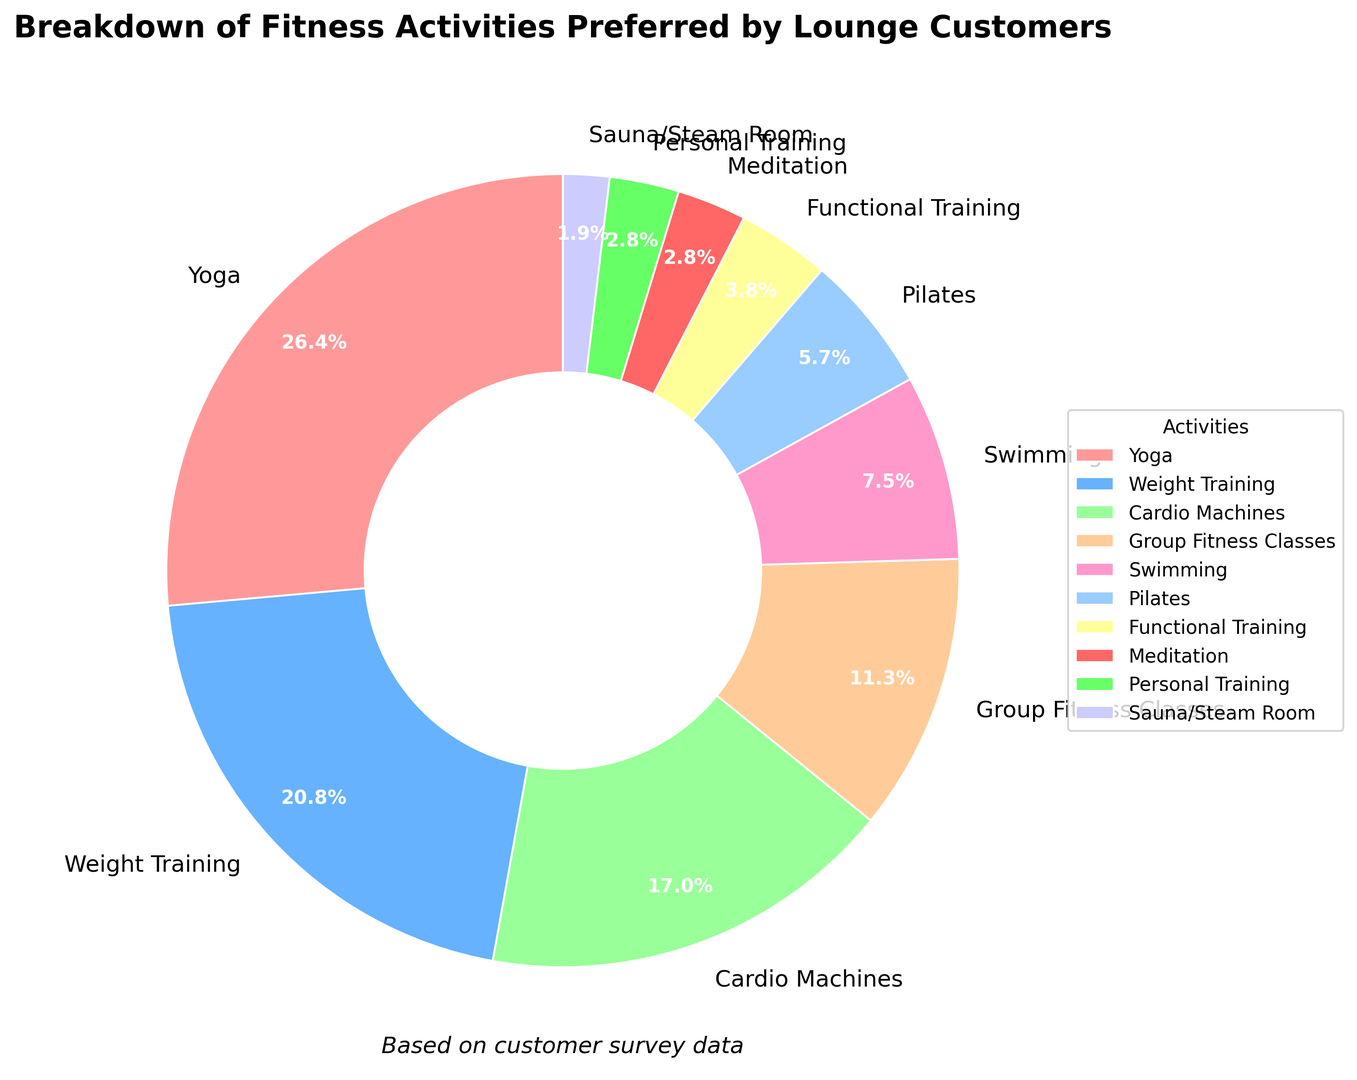Which activity is preferred by the highest percentage of lounge customers? By looking at the pie chart, it is clear that the slice labeled "Yoga" has the largest proportion, with 28%.
Answer: Yoga How does the preference for Weight Training compare to Yoga? The percentage for Weight Training is 22%, while Yoga is at 28%. Therefore, Yoga is preferred by a higher percentage of lounge customers than Weight Training.
Answer: Yoga is preferred more than Weight Training What is the combined percentage of customers who prefer Cardio Machines and Weight Training? Cardio Machines have 18% and Weight Training has 22%. Adding these gives 18% + 22% = 40%.
Answer: 40% Which two activities have the smallest percentages, and what are their combined percentages? The two smallest slices are Sauna/Steam Room with 2% and Meditation with 3%. Adding these gives 2% + 3% = 5%.
Answer: Sauna/Steam Room and Meditation; 5% What percentage of customers prefer either Group Fitness Classes or Swimming? Group Fitness Classes have 12% and Swimming has 8%. Adding these gives 12% + 8% = 20%.
Answer: 20% Which activity has a preference closest to 10%? By looking at the pie chart, it is clear that Group Fitness Classes are the closest to 10% with a preference of 12%.
Answer: Group Fitness Classes Which activities have a preference higher than 15%? By examining the chart, we see that Yoga (28%), Weight Training (22%), and Cardio Machines (18%) each have a preference higher than 15%.
Answer: Yoga, Weight Training, Cardio Machines What is the difference between the percentages for Pilates and Functional Training? Pilates has a percentage of 6% and Functional Training has 4%. The difference is 6% - 4% = 2%.
Answer: 2% How many activities have a preference of 5% or less? By looking at the pie chart, we see that Functional Training (4%), Meditation (3%), Personal Training (3%), and Sauna/Steam Room (2%) each have a preference of 5% or less. There are 4 such activities.
Answer: 4 What is the total percentage of customers who prefer either Yoga, Weight Training, or Cardio Machines? Yoga has 28%, Weight Training has 22%, and Cardio Machines have 18%. Adding these gives 28% + 22% + 18% = 68%.
Answer: 68% 